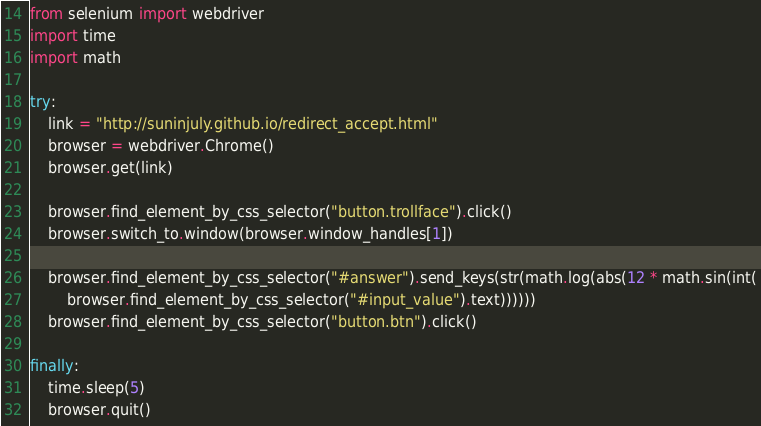Convert code to text. <code><loc_0><loc_0><loc_500><loc_500><_Python_>from selenium import webdriver
import time
import math

try:
    link = "http://suninjuly.github.io/redirect_accept.html"
    browser = webdriver.Chrome()
    browser.get(link)

    browser.find_element_by_css_selector("button.trollface").click()
    browser.switch_to.window(browser.window_handles[1])

    browser.find_element_by_css_selector("#answer").send_keys(str(math.log(abs(12 * math.sin(int(
        browser.find_element_by_css_selector("#input_value").text))))))
    browser.find_element_by_css_selector("button.btn").click()

finally:
    time.sleep(5)
    browser.quit()
</code> 